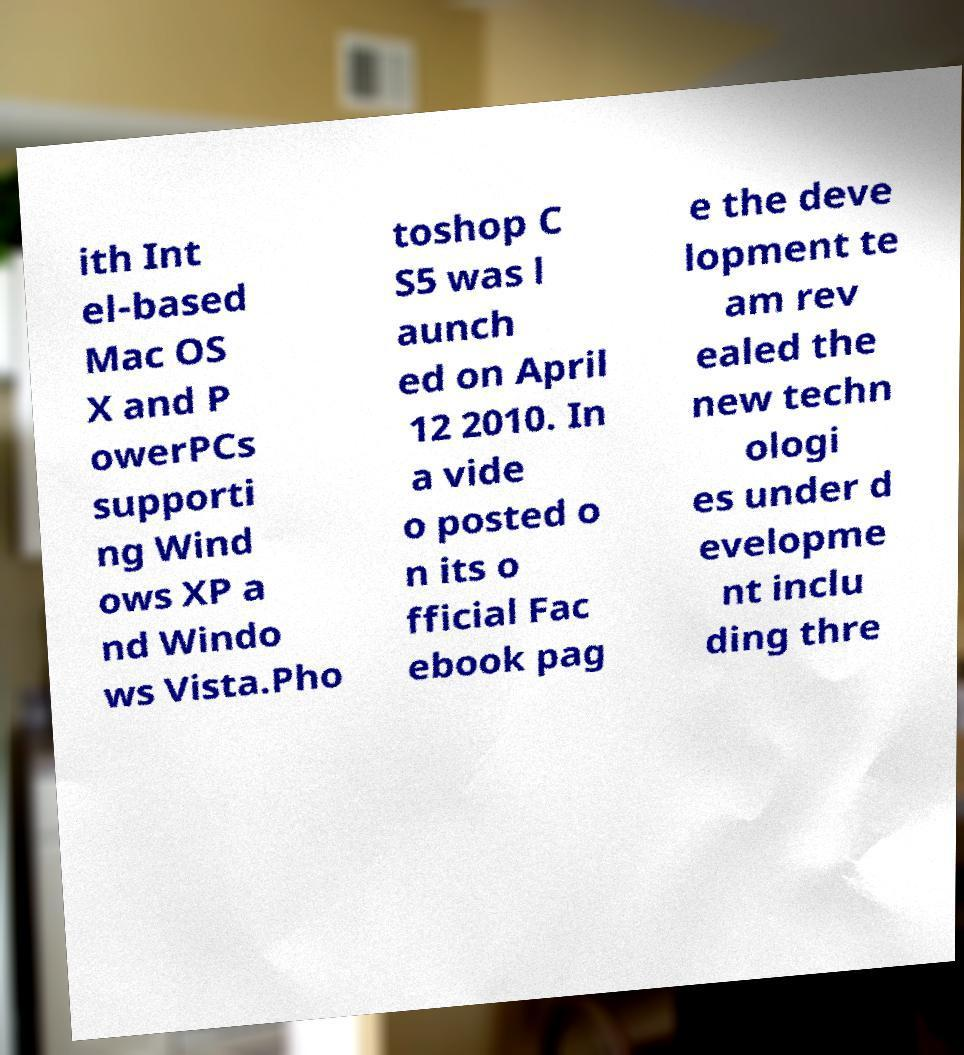Please identify and transcribe the text found in this image. ith Int el-based Mac OS X and P owerPCs supporti ng Wind ows XP a nd Windo ws Vista.Pho toshop C S5 was l aunch ed on April 12 2010. In a vide o posted o n its o fficial Fac ebook pag e the deve lopment te am rev ealed the new techn ologi es under d evelopme nt inclu ding thre 